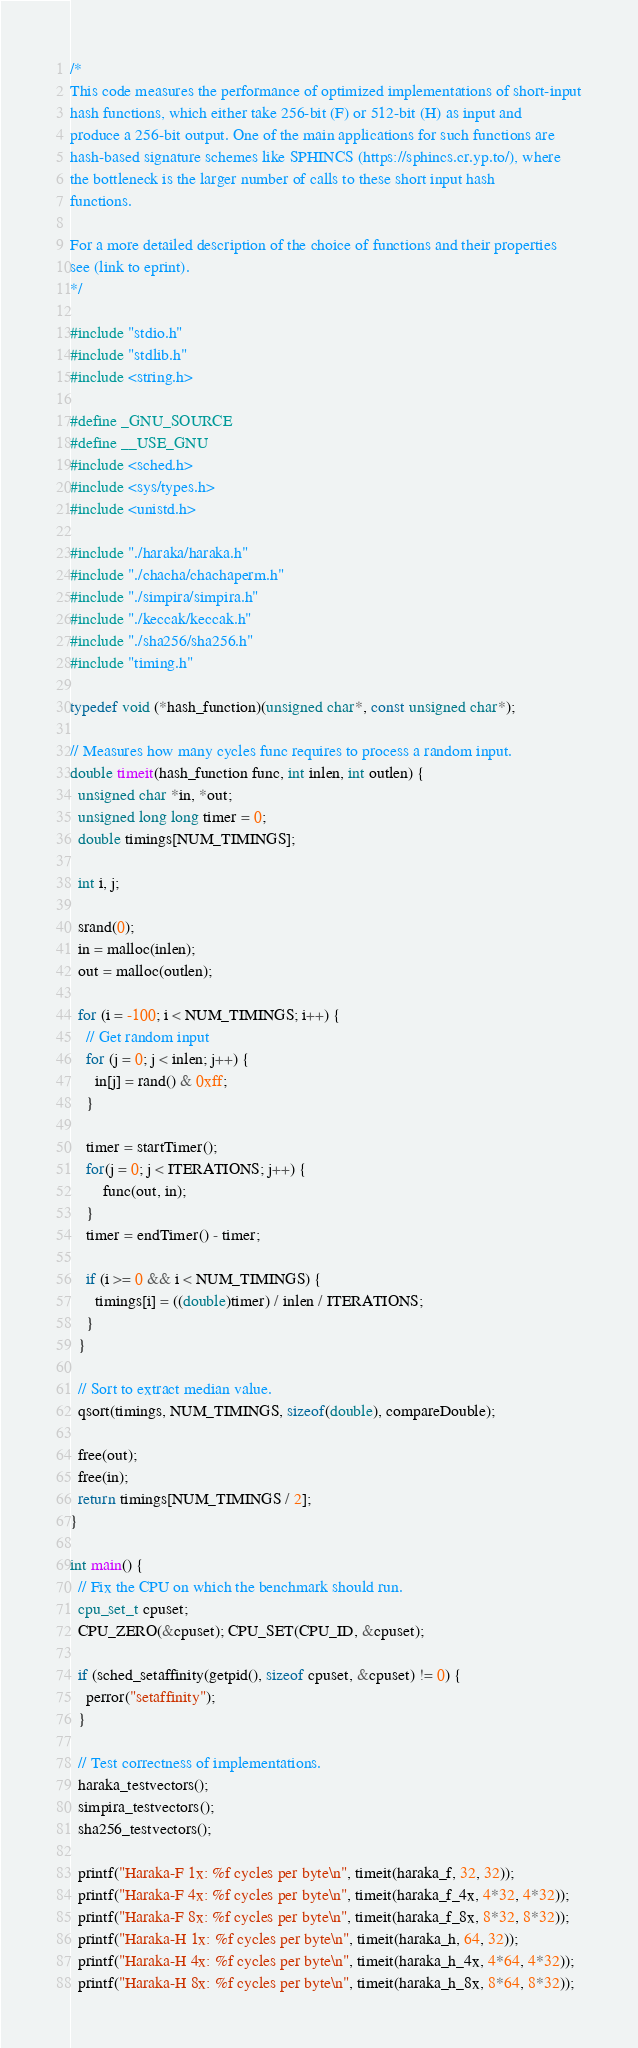Convert code to text. <code><loc_0><loc_0><loc_500><loc_500><_C_>/*
This code measures the performance of optimized implementations of short-input
hash functions, which either take 256-bit (F) or 512-bit (H) as input and
produce a 256-bit output. One of the main applications for such functions are
hash-based signature schemes like SPHINCS (https://sphincs.cr.yp.to/), where
the bottleneck is the larger number of calls to these short input hash
functions.

For a more detailed description of the choice of functions and their properties
see (link to eprint).
*/

#include "stdio.h"
#include "stdlib.h"
#include <string.h>

#define _GNU_SOURCE
#define __USE_GNU
#include <sched.h>
#include <sys/types.h>
#include <unistd.h>

#include "./haraka/haraka.h"
#include "./chacha/chachaperm.h"
#include "./simpira/simpira.h"
#include "./keccak/keccak.h"
#include "./sha256/sha256.h"
#include "timing.h"

typedef void (*hash_function)(unsigned char*, const unsigned char*);

// Measures how many cycles func requires to process a random input.
double timeit(hash_function func, int inlen, int outlen) {
  unsigned char *in, *out;
  unsigned long long timer = 0;
  double timings[NUM_TIMINGS];

  int i, j;

  srand(0);
  in = malloc(inlen);
  out = malloc(outlen);

  for (i = -100; i < NUM_TIMINGS; i++) {
    // Get random input
    for (j = 0; j < inlen; j++) {
      in[j] = rand() & 0xff;
    }

    timer = startTimer();
    for(j = 0; j < ITERATIONS; j++) {
        func(out, in);
    }
    timer = endTimer() - timer;

    if (i >= 0 && i < NUM_TIMINGS) {
      timings[i] = ((double)timer) / inlen / ITERATIONS;
    }
  }

  // Sort to extract median value.
  qsort(timings, NUM_TIMINGS, sizeof(double), compareDouble);

  free(out);
  free(in);
  return timings[NUM_TIMINGS / 2];
}

int main() {
  // Fix the CPU on which the benchmark should run.
  cpu_set_t cpuset;
  CPU_ZERO(&cpuset); CPU_SET(CPU_ID, &cpuset);

  if (sched_setaffinity(getpid(), sizeof cpuset, &cpuset) != 0) {
    perror("setaffinity");
  }

  // Test correctness of implementations.
  haraka_testvectors();
  simpira_testvectors();
  sha256_testvectors();

  printf("Haraka-F 1x: %f cycles per byte\n", timeit(haraka_f, 32, 32));
  printf("Haraka-F 4x: %f cycles per byte\n", timeit(haraka_f_4x, 4*32, 4*32));
  printf("Haraka-F 8x: %f cycles per byte\n", timeit(haraka_f_8x, 8*32, 8*32));
  printf("Haraka-H 1x: %f cycles per byte\n", timeit(haraka_h, 64, 32));
  printf("Haraka-H 4x: %f cycles per byte\n", timeit(haraka_h_4x, 4*64, 4*32));
  printf("Haraka-H 8x: %f cycles per byte\n", timeit(haraka_h_8x, 8*64, 8*32));
</code> 